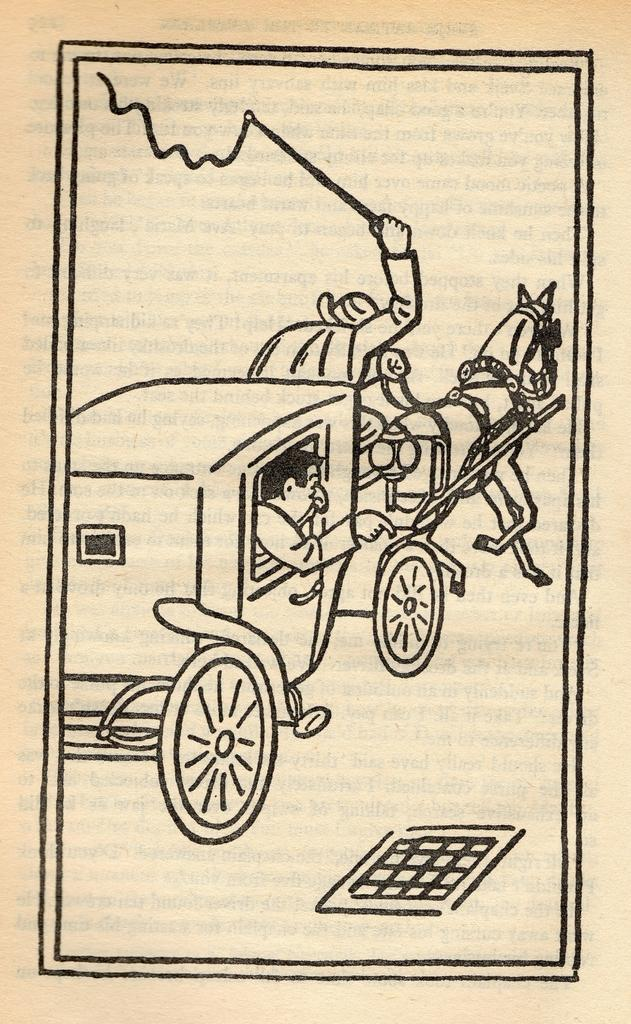What is the main subject of the paper in the image? The main subject of the paper in the image is a sketch. What does the sketch depict? The sketch depicts a cart. What can be seen inside the cart in the sketch? The cart contains persons and an animal. What is the person holding in the sketch? There is a person holding an object in the sketch. What type of skin can be seen on the vegetable in the image? There is no vegetable present in the image, and therefore no skin can be observed. 